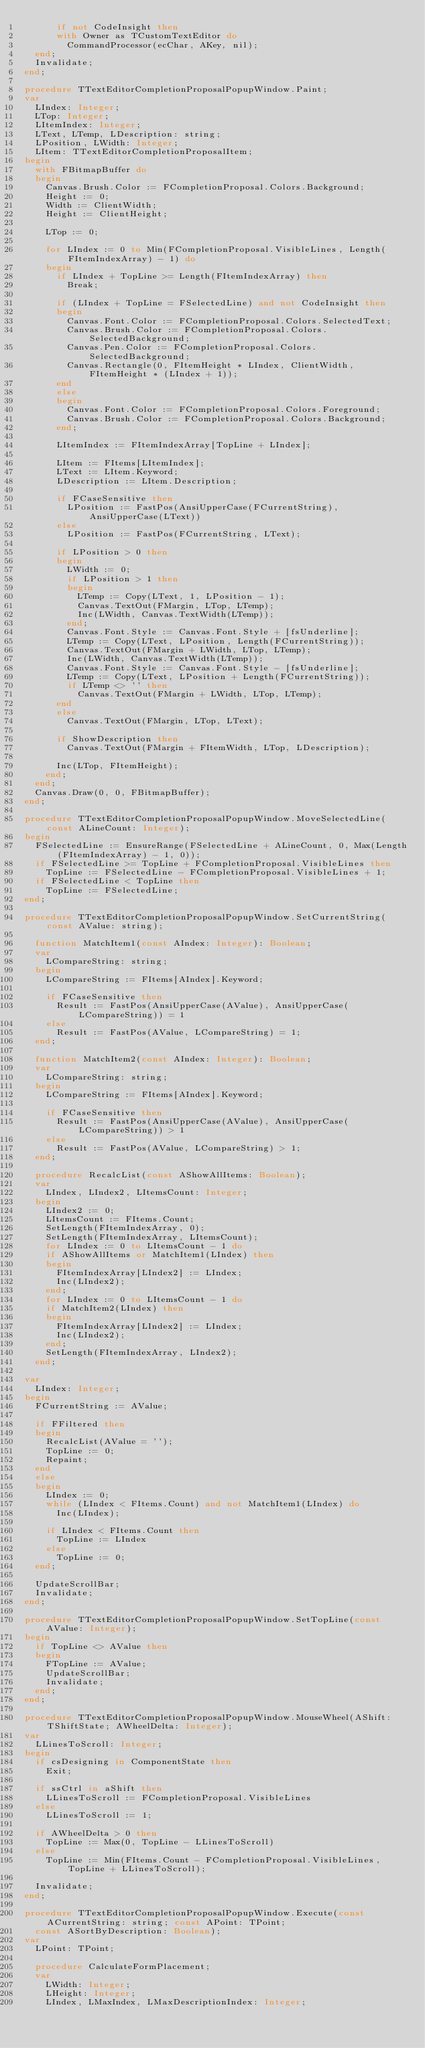Convert code to text. <code><loc_0><loc_0><loc_500><loc_500><_Pascal_>      if not CodeInsight then
      with Owner as TCustomTextEditor do
        CommandProcessor(ecChar, AKey, nil);
  end;
  Invalidate;
end;

procedure TTextEditorCompletionProposalPopupWindow.Paint;
var
  LIndex: Integer;
  LTop: Integer;
  LItemIndex: Integer;
  LText, LTemp, LDescription: string;
  LPosition, LWidth: Integer;
  LItem: TTextEditorCompletionProposalItem;
begin
  with FBitmapBuffer do
  begin
    Canvas.Brush.Color := FCompletionProposal.Colors.Background;
    Height := 0;
    Width := ClientWidth;
    Height := ClientHeight;

    LTop := 0;

    for LIndex := 0 to Min(FCompletionProposal.VisibleLines, Length(FItemIndexArray) - 1) do
    begin
      if LIndex + TopLine >= Length(FItemIndexArray) then
        Break;

      if (LIndex + TopLine = FSelectedLine) and not CodeInsight then
      begin
        Canvas.Font.Color := FCompletionProposal.Colors.SelectedText;
        Canvas.Brush.Color := FCompletionProposal.Colors.SelectedBackground;
        Canvas.Pen.Color := FCompletionProposal.Colors.SelectedBackground;
        Canvas.Rectangle(0, FItemHeight * LIndex, ClientWidth, FItemHeight * (LIndex + 1));
      end
      else
      begin
        Canvas.Font.Color := FCompletionProposal.Colors.Foreground;
        Canvas.Brush.Color := FCompletionProposal.Colors.Background;
      end;

      LItemIndex := FItemIndexArray[TopLine + LIndex];

      LItem := FItems[LItemIndex];
      LText := LItem.Keyword;
      LDescription := LItem.Description;

      if FCaseSensitive then
        LPosition := FastPos(AnsiUpperCase(FCurrentString), AnsiUpperCase(LText))
      else
        LPosition := FastPos(FCurrentString, LText);

      if LPosition > 0 then
      begin
        LWidth := 0;
        if LPosition > 1 then
        begin
          LTemp := Copy(LText, 1, LPosition - 1);
          Canvas.TextOut(FMargin, LTop, LTemp);
          Inc(LWidth, Canvas.TextWidth(LTemp));
        end;
        Canvas.Font.Style := Canvas.Font.Style + [fsUnderline];
        LTemp := Copy(LText, LPosition, Length(FCurrentString));
        Canvas.TextOut(FMargin + LWidth, LTop, LTemp);
        Inc(LWidth, Canvas.TextWidth(LTemp));
        Canvas.Font.Style := Canvas.Font.Style - [fsUnderline];
        LTemp := Copy(LText, LPosition + Length(FCurrentString));
        if LTemp <> '' then
          Canvas.TextOut(FMargin + LWidth, LTop, LTemp);
      end
      else
        Canvas.TextOut(FMargin, LTop, LText);

      if ShowDescription then
        Canvas.TextOut(FMargin + FItemWidth, LTop, LDescription);

      Inc(LTop, FItemHeight);
    end;
  end;
  Canvas.Draw(0, 0, FBitmapBuffer);
end;

procedure TTextEditorCompletionProposalPopupWindow.MoveSelectedLine(const ALineCount: Integer);
begin
  FSelectedLine := EnsureRange(FSelectedLine + ALineCount, 0, Max(Length(FItemIndexArray) - 1, 0));
  if FSelectedLine >= TopLine + FCompletionProposal.VisibleLines then
    TopLine := FSelectedLine - FCompletionProposal.VisibleLines + 1;
  if FSelectedLine < TopLine then
    TopLine := FSelectedLine;
end;

procedure TTextEditorCompletionProposalPopupWindow.SetCurrentString(const AValue: string);

  function MatchItem1(const AIndex: Integer): Boolean;
  var
    LCompareString: string;
  begin
    LCompareString := FItems[AIndex].Keyword;

    if FCaseSensitive then
      Result := FastPos(AnsiUpperCase(AValue), AnsiUpperCase(LCompareString)) = 1
    else
      Result := FastPos(AValue, LCompareString) = 1;
  end;

  function MatchItem2(const AIndex: Integer): Boolean;
  var
    LCompareString: string;
  begin
    LCompareString := FItems[AIndex].Keyword;

    if FCaseSensitive then
      Result := FastPos(AnsiUpperCase(AValue), AnsiUpperCase(LCompareString)) > 1
    else
      Result := FastPos(AValue, LCompareString) > 1;
  end;

  procedure RecalcList(const AShowAllItems: Boolean);
  var
    LIndex, LIndex2, LItemsCount: Integer;
  begin
    LIndex2 := 0;
    LItemsCount := FItems.Count;
    SetLength(FItemIndexArray, 0);
    SetLength(FItemIndexArray, LItemsCount);
    for LIndex := 0 to LItemsCount - 1 do
    if AShowAllItems or MatchItem1(LIndex) then
    begin
      FItemIndexArray[LIndex2] := LIndex;
      Inc(LIndex2);
    end;
    for LIndex := 0 to LItemsCount - 1 do
    if MatchItem2(LIndex) then
    begin
      FItemIndexArray[LIndex2] := LIndex;
      Inc(LIndex2);
    end;
    SetLength(FItemIndexArray, LIndex2);
  end;

var
  LIndex: Integer;
begin
  FCurrentString := AValue;

  if FFiltered then
  begin
    RecalcList(AValue = '');
    TopLine := 0;
    Repaint;
  end
  else
  begin
    LIndex := 0;
    while (LIndex < FItems.Count) and not MatchItem1(LIndex) do
      Inc(LIndex);

    if LIndex < FItems.Count then
      TopLine := LIndex
    else
      TopLine := 0;
  end;

  UpdateScrollBar;
  Invalidate;
end;

procedure TTextEditorCompletionProposalPopupWindow.SetTopLine(const AValue: Integer);
begin
  if TopLine <> AValue then
  begin
    FTopLine := AValue;
    UpdateScrollBar;
    Invalidate;
  end;
end;

procedure TTextEditorCompletionProposalPopupWindow.MouseWheel(AShift: TShiftState; AWheelDelta: Integer);
var
  LLinesToScroll: Integer;
begin
  if csDesigning in ComponentState then
    Exit;

  if ssCtrl in aShift then
    LLinesToScroll := FCompletionProposal.VisibleLines
  else
    LLinesToScroll := 1;

  if AWheelDelta > 0 then
    TopLine := Max(0, TopLine - LLinesToScroll)
  else
    TopLine := Min(FItems.Count - FCompletionProposal.VisibleLines, TopLine + LLinesToScroll);

  Invalidate;
end;

procedure TTextEditorCompletionProposalPopupWindow.Execute(const ACurrentString: string; const APoint: TPoint;
  const ASortByDescription: Boolean);
var
  LPoint: TPoint;

  procedure CalculateFormPlacement;
  var
    LWidth: Integer;
    LHeight: Integer;
    LIndex, LMaxIndex, LMaxDescriptionIndex: Integer;</code> 